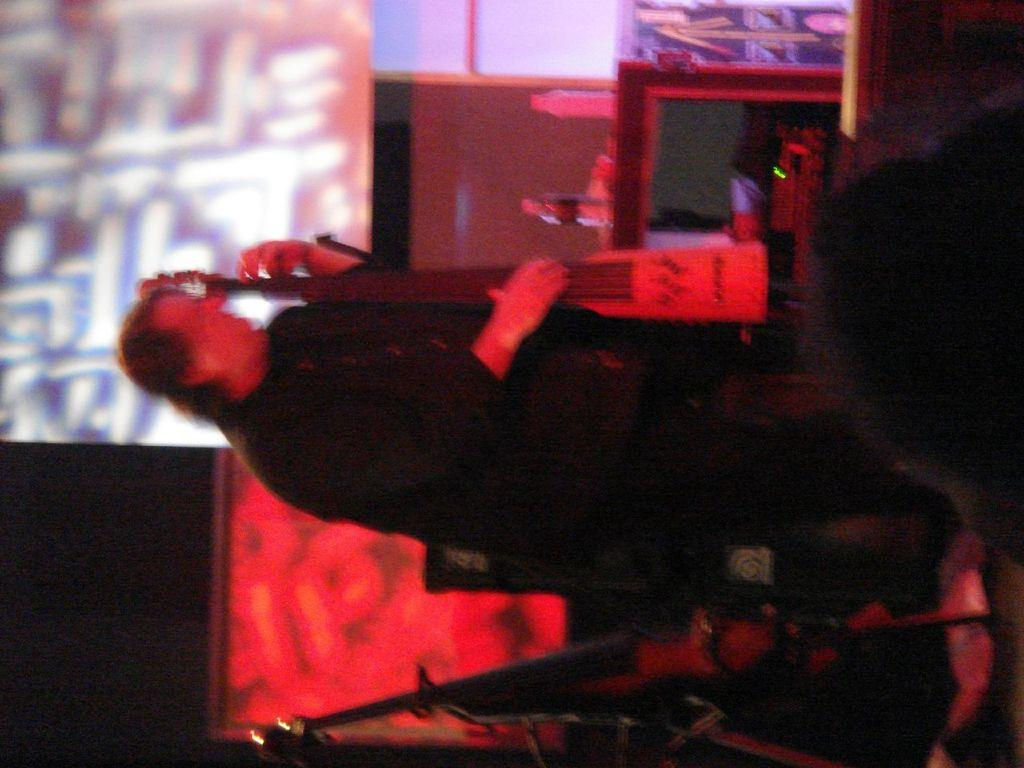What is the person in the image doing? The person is standing and holding a musical instrument. What objects are on the table in the image? There are bottles on a table in the image. What else can be seen in the background of the image? There are other items visible in the background of the image. How does the person's digestion affect the musical instrument in the image? There is no information about the person's digestion in the image, and it does not affect the musical instrument. 